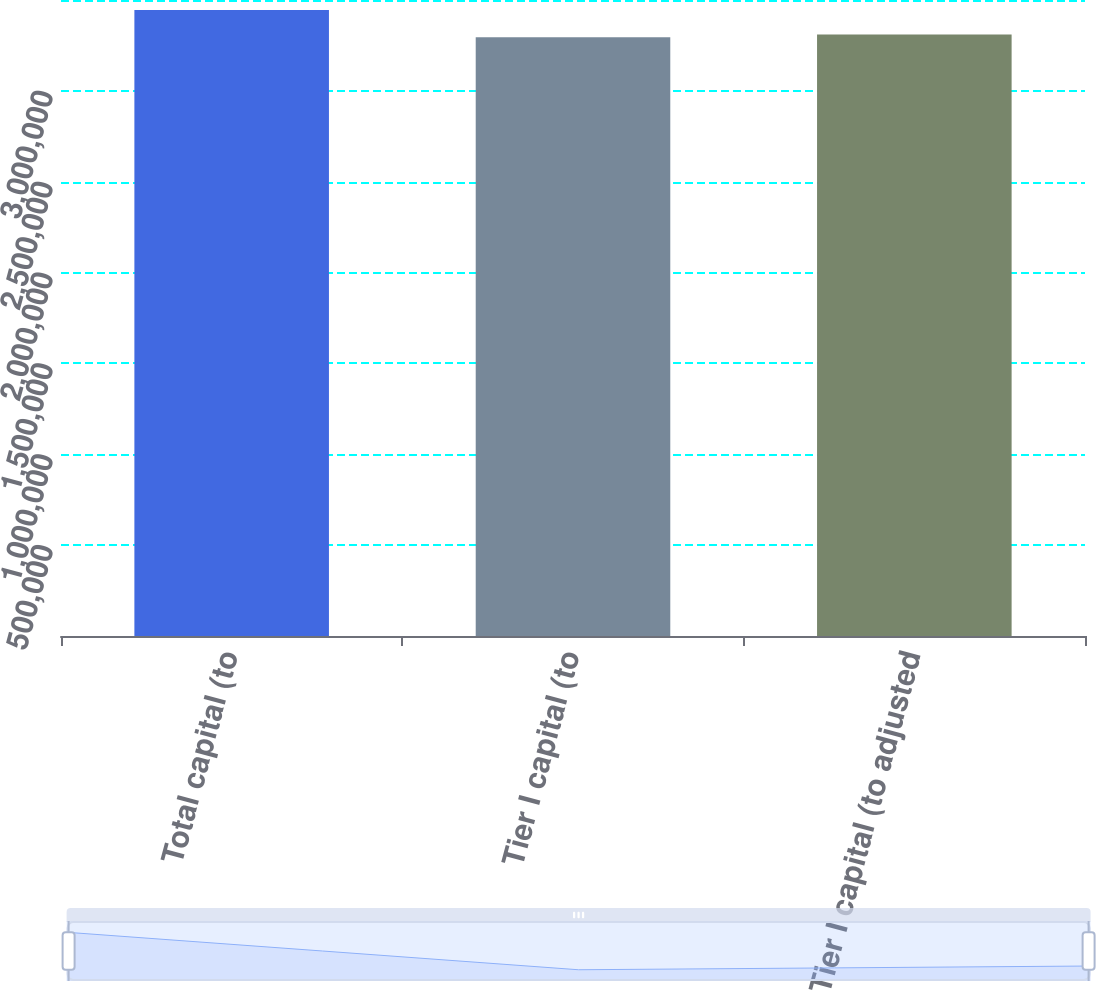<chart> <loc_0><loc_0><loc_500><loc_500><bar_chart><fcel>Total capital (to<fcel>Tier I capital (to<fcel>Tier I capital (to adjusted<nl><fcel>3.44514e+06<fcel>3.2946e+06<fcel>3.30965e+06<nl></chart> 